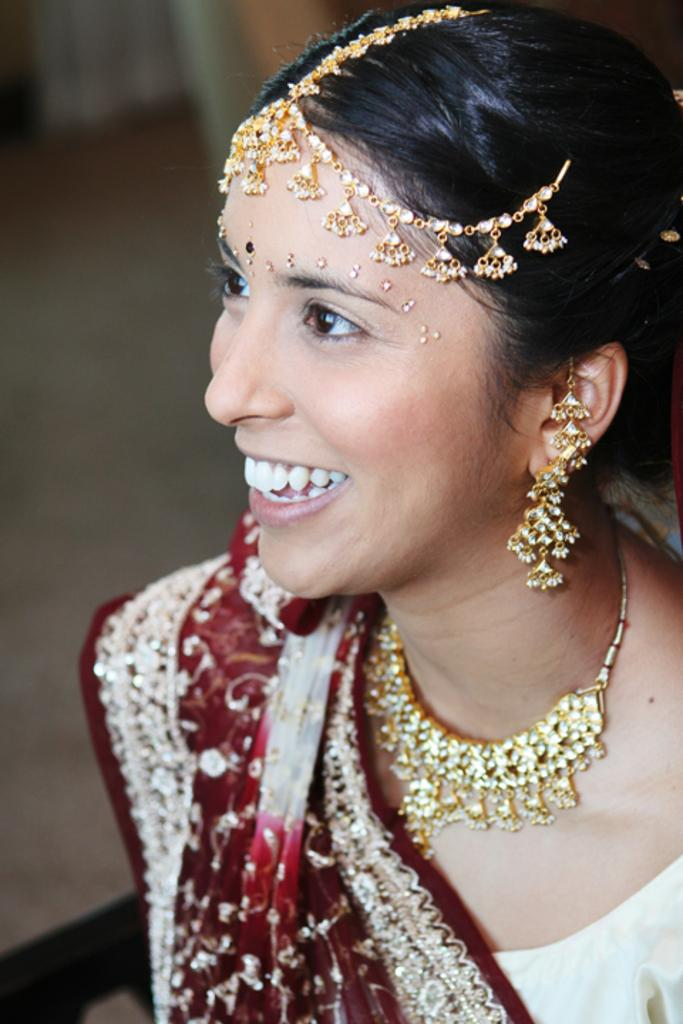Who is the main subject in the image? There is a lady in the image. What is the lady wearing in the image? The lady is wearing an ornament in the image. Can you describe the background of the image? The background of the image is blurry. What type of cast can be seen on the lady's arm in the image? There is no cast visible on the lady's arm in the image. How many quivers are present in the image? There are no quivers present in the image. 